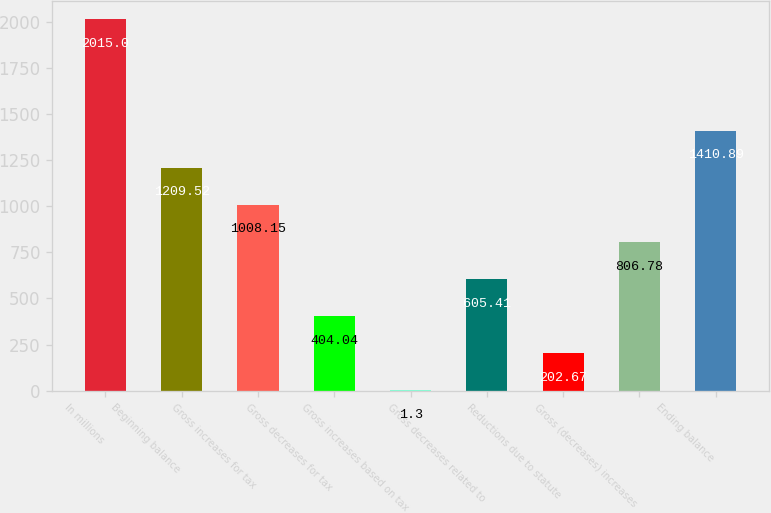<chart> <loc_0><loc_0><loc_500><loc_500><bar_chart><fcel>In millions<fcel>Beginning balance<fcel>Gross increases for tax<fcel>Gross decreases for tax<fcel>Gross increases based on tax<fcel>Gross decreases related to<fcel>Reductions due to statute<fcel>Gross (decreases) increases<fcel>Ending balance<nl><fcel>2015<fcel>1209.52<fcel>1008.15<fcel>404.04<fcel>1.3<fcel>605.41<fcel>202.67<fcel>806.78<fcel>1410.89<nl></chart> 